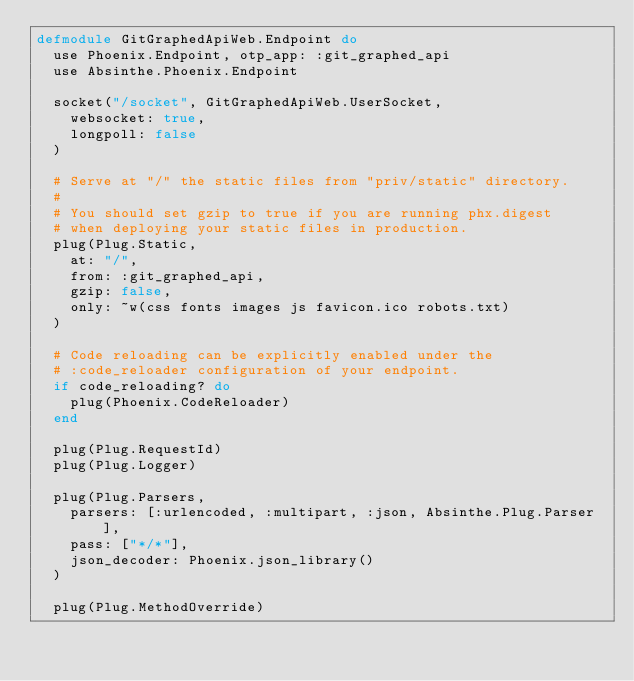Convert code to text. <code><loc_0><loc_0><loc_500><loc_500><_Elixir_>defmodule GitGraphedApiWeb.Endpoint do
  use Phoenix.Endpoint, otp_app: :git_graphed_api
  use Absinthe.Phoenix.Endpoint

  socket("/socket", GitGraphedApiWeb.UserSocket,
    websocket: true,
    longpoll: false
  )

  # Serve at "/" the static files from "priv/static" directory.
  #
  # You should set gzip to true if you are running phx.digest
  # when deploying your static files in production.
  plug(Plug.Static,
    at: "/",
    from: :git_graphed_api,
    gzip: false,
    only: ~w(css fonts images js favicon.ico robots.txt)
  )

  # Code reloading can be explicitly enabled under the
  # :code_reloader configuration of your endpoint.
  if code_reloading? do
    plug(Phoenix.CodeReloader)
  end

  plug(Plug.RequestId)
  plug(Plug.Logger)

  plug(Plug.Parsers,
    parsers: [:urlencoded, :multipart, :json, Absinthe.Plug.Parser],
    pass: ["*/*"],
    json_decoder: Phoenix.json_library()
  )

  plug(Plug.MethodOverride)</code> 